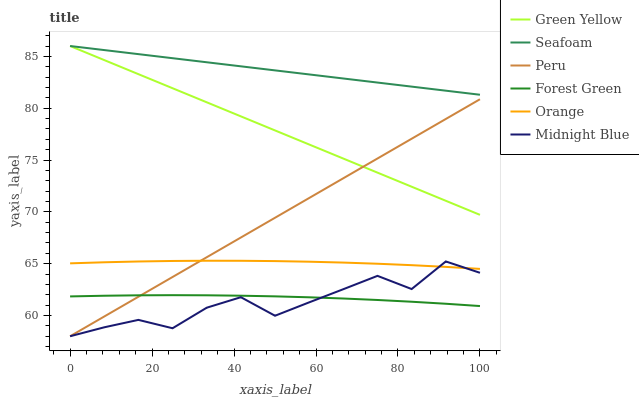Does Midnight Blue have the minimum area under the curve?
Answer yes or no. Yes. Does Seafoam have the maximum area under the curve?
Answer yes or no. Yes. Does Forest Green have the minimum area under the curve?
Answer yes or no. No. Does Forest Green have the maximum area under the curve?
Answer yes or no. No. Is Peru the smoothest?
Answer yes or no. Yes. Is Midnight Blue the roughest?
Answer yes or no. Yes. Is Seafoam the smoothest?
Answer yes or no. No. Is Seafoam the roughest?
Answer yes or no. No. Does Midnight Blue have the lowest value?
Answer yes or no. Yes. Does Forest Green have the lowest value?
Answer yes or no. No. Does Green Yellow have the highest value?
Answer yes or no. Yes. Does Forest Green have the highest value?
Answer yes or no. No. Is Midnight Blue less than Seafoam?
Answer yes or no. Yes. Is Seafoam greater than Forest Green?
Answer yes or no. Yes. Does Green Yellow intersect Seafoam?
Answer yes or no. Yes. Is Green Yellow less than Seafoam?
Answer yes or no. No. Is Green Yellow greater than Seafoam?
Answer yes or no. No. Does Midnight Blue intersect Seafoam?
Answer yes or no. No. 